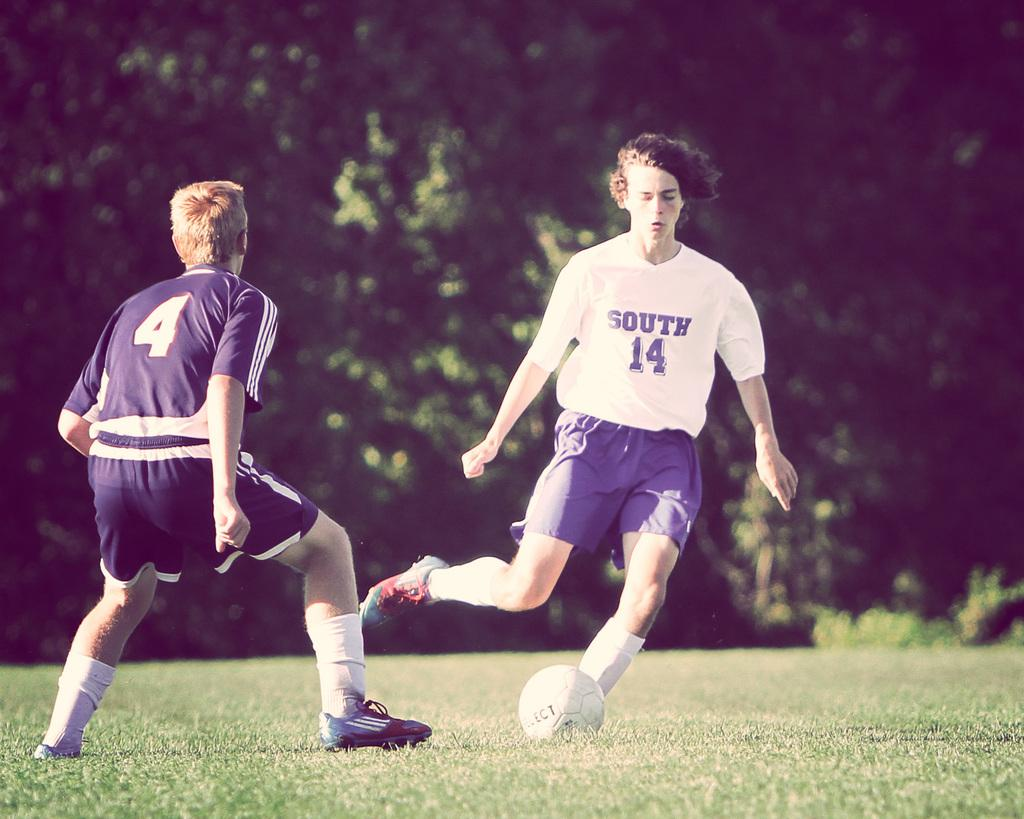<image>
Give a short and clear explanation of the subsequent image. A guy is playing soccer with the number 14 on his shirt. 